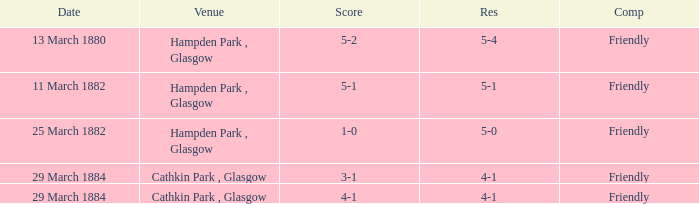Which item resulted in a score of 4-1? 3-1, 4-1. 